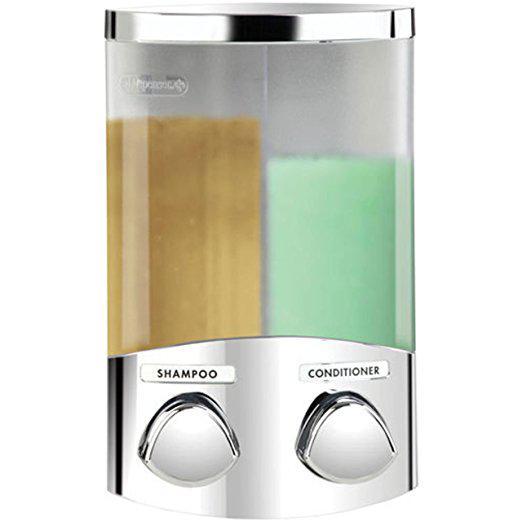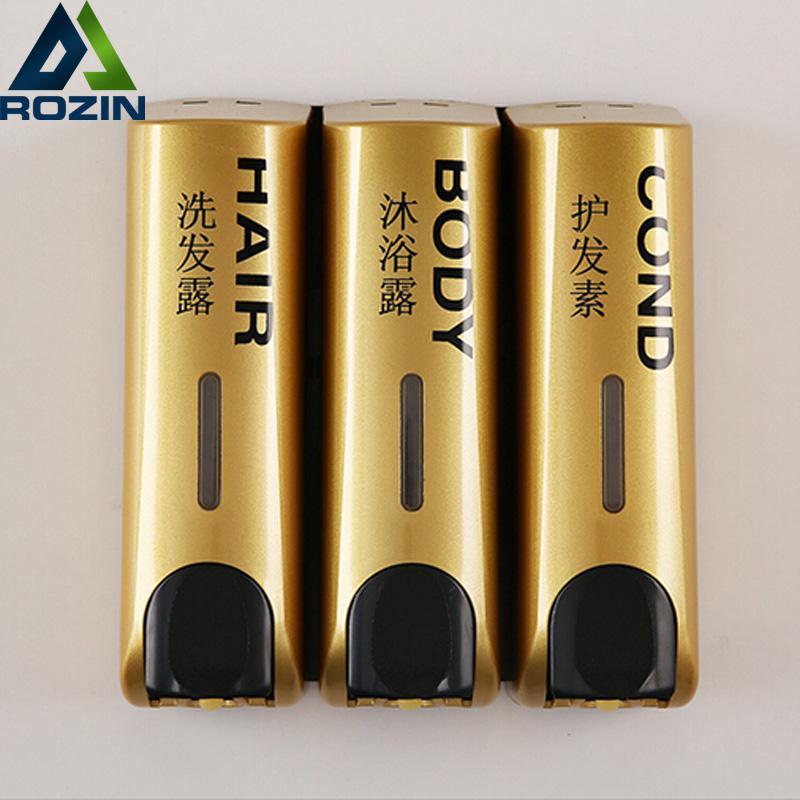The first image is the image on the left, the second image is the image on the right. Examine the images to the left and right. Is the description "An image shows three side-by-side gold dispensers with black push buttons." accurate? Answer yes or no. Yes. The first image is the image on the left, the second image is the image on the right. Assess this claim about the two images: "There are two cleaning products on the left and three on the right.". Correct or not? Answer yes or no. Yes. 